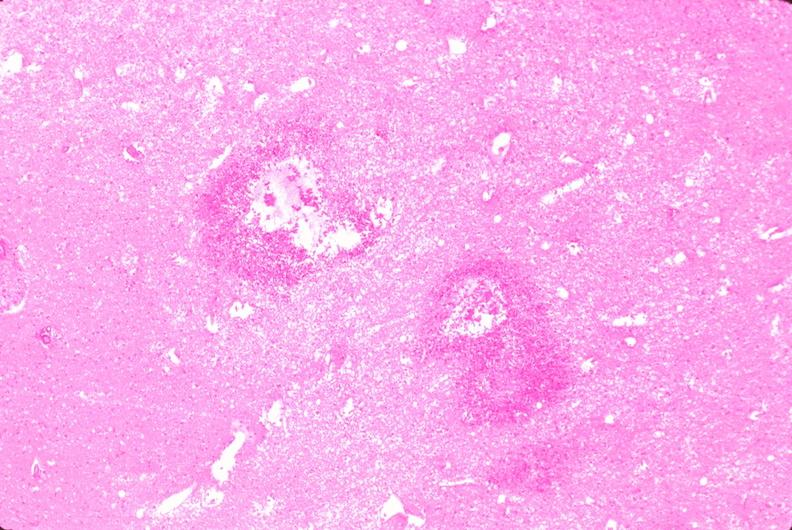does this image show brain, infarct due to ruptured saccular aneurysm and thrombosis of right middle cerebral artery?
Answer the question using a single word or phrase. Yes 